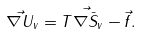<formula> <loc_0><loc_0><loc_500><loc_500>\vec { \nabla U } _ { v } = T \vec { \nabla \bar { S } } _ { v } - \vec { f } .</formula> 